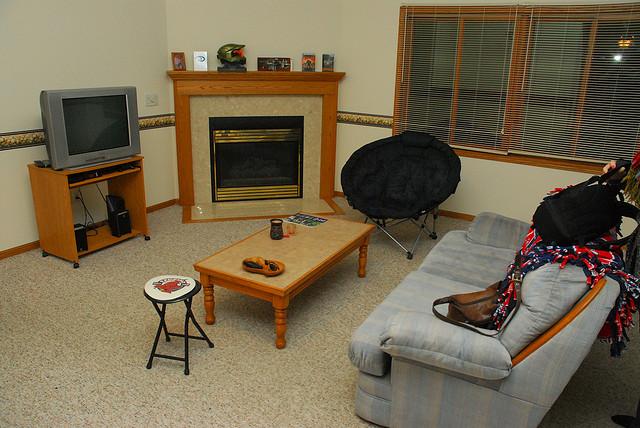Where are tiles?
Quick response, please. Fireplace. Is the fireplace on?
Concise answer only. No. Is there a purse?
Short answer required. Yes. What room is this?
Answer briefly. Living room. What kind of room is this?
Keep it brief. Living room. Is there a fireplace in the room?
Write a very short answer. Yes. What color is the mat on top of the chair?
Answer briefly. Black. 